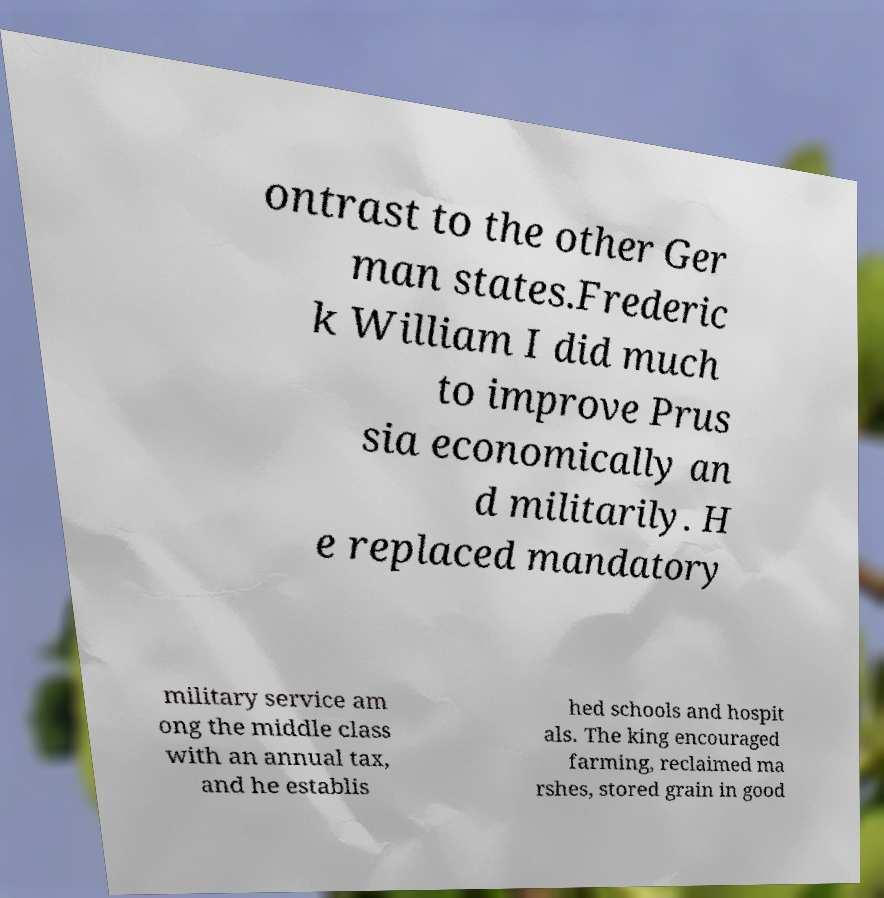Please identify and transcribe the text found in this image. ontrast to the other Ger man states.Frederic k William I did much to improve Prus sia economically an d militarily. H e replaced mandatory military service am ong the middle class with an annual tax, and he establis hed schools and hospit als. The king encouraged farming, reclaimed ma rshes, stored grain in good 